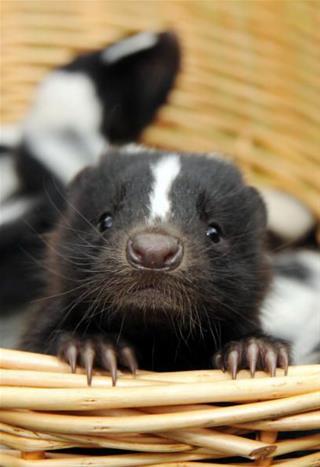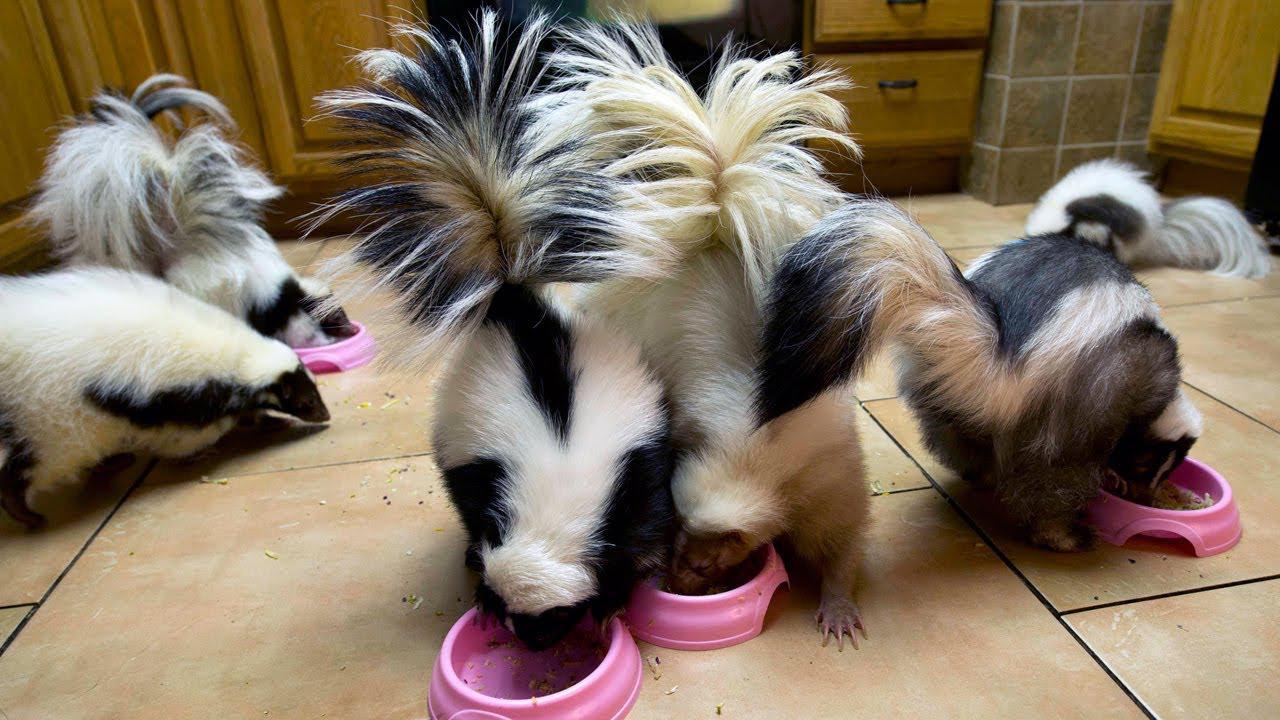The first image is the image on the left, the second image is the image on the right. For the images displayed, is the sentence "The left image contains at least one skunk in basket." factually correct? Answer yes or no. Yes. The first image is the image on the left, the second image is the image on the right. Given the left and right images, does the statement "At least one camera-gazing skunk has both its front paws on the edge of a basket." hold true? Answer yes or no. Yes. 